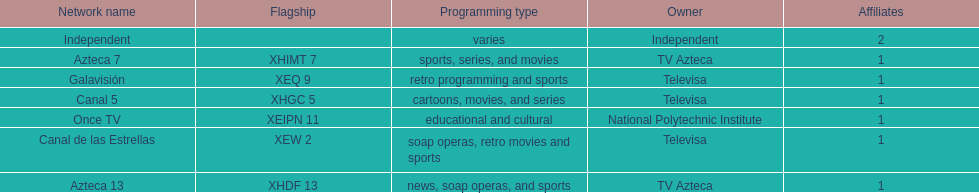How many affiliates does galavision have? 1. Could you help me parse every detail presented in this table? {'header': ['Network name', 'Flagship', 'Programming type', 'Owner', 'Affiliates'], 'rows': [['Independent', '', 'varies', 'Independent', '2'], ['Azteca 7', 'XHIMT 7', 'sports, series, and movies', 'TV Azteca', '1'], ['Galavisión', 'XEQ 9', 'retro programming and sports', 'Televisa', '1'], ['Canal 5', 'XHGC 5', 'cartoons, movies, and series', 'Televisa', '1'], ['Once TV', 'XEIPN 11', 'educational and cultural', 'National Polytechnic Institute', '1'], ['Canal de las Estrellas', 'XEW 2', 'soap operas, retro movies and sports', 'Televisa', '1'], ['Azteca 13', 'XHDF 13', 'news, soap operas, and sports', 'TV Azteca', '1']]} 